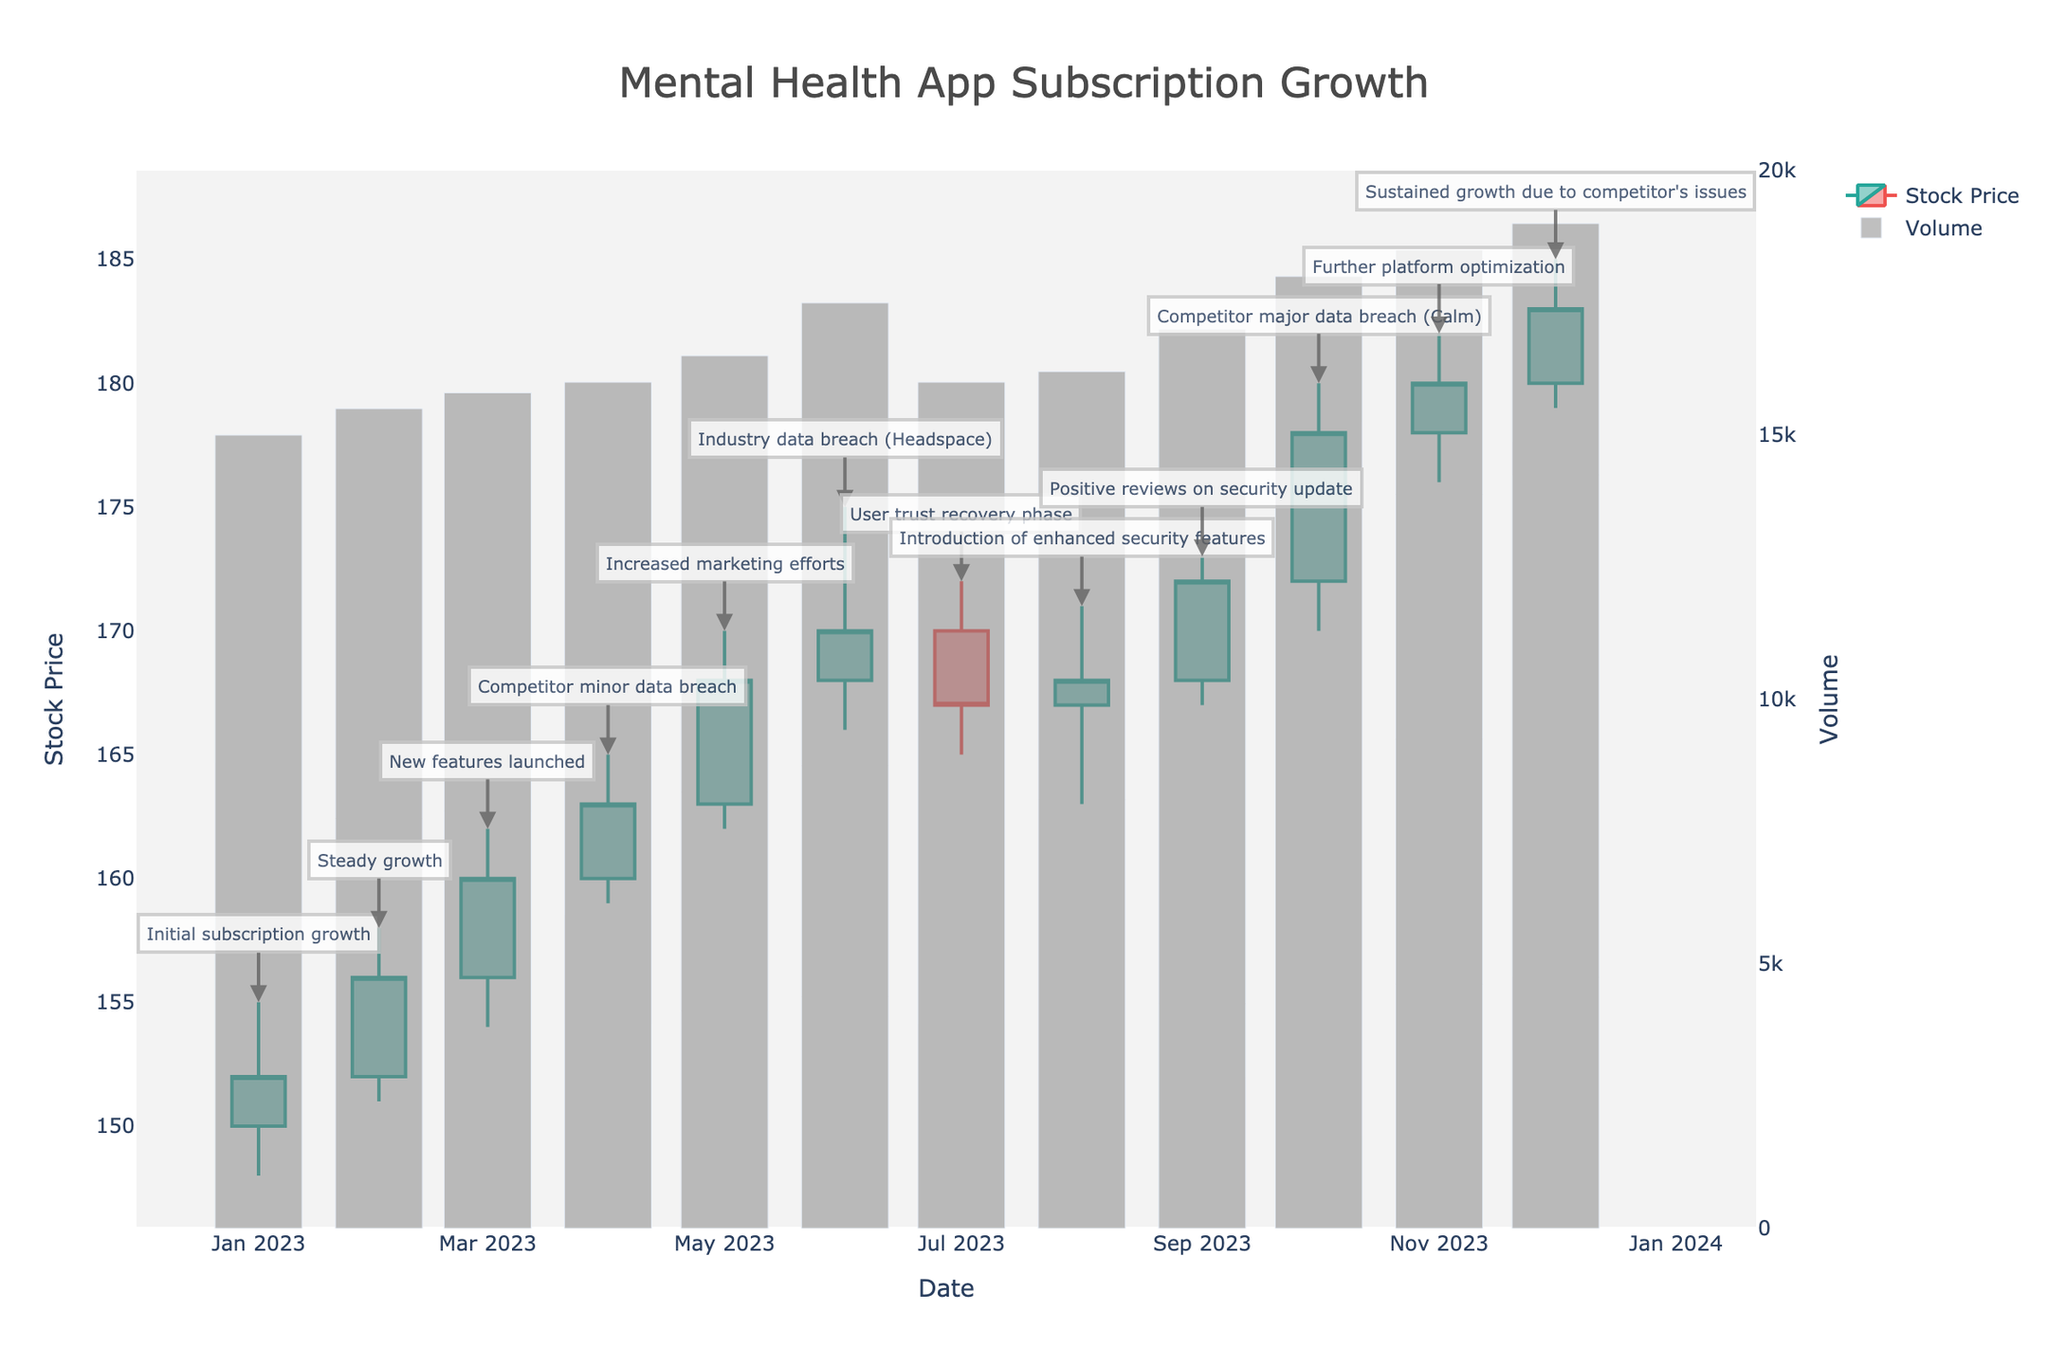what is the title of the candlestick plot? The title of the candlestick plot is visually presented at the top, center-aligned, and typically displayed in a larger and bolder font to make it stand out.
Answer: Mental Health App Subscription Growth How many data points (months) are depicted in the plot? To determine the number of data points, we count the distinct dates on the x-axis. Each date represents a month.
Answer: 12 When did the stock price reach its highest high? We need to identify the highest point on the plot's y-axis representing the stock price, then check the associated date on the x-axis.
Answer: October 2023 What is the volume trend in November 2023 compared to the previous month? First, identify the volume bars for October and November 2023. Then, compare their lengths to see if November's volume is higher or lower.
Answer: Higher Which event correlates with the largest increase in volume? Look for the month with the tallest volume bar and then refer to the comments/annotations for that month in the plot.
Answer: Competitor major data breach (Calm) What was the stock price at the close of June 2023? Locate the candlestick for June 2023 and identify the closing price label, which is shown by the top or bottom of the thicker part of the candlestick, depending on the price movement.
Answer: 170 How did the introduction of enhanced security features in August 2023 impact the stock price? Examine the candlestick for August 2023 and observe any significant price changes from the previous month to determine the trend.
Answer: Slight increase (price remained stable around 167 to 168) Compare the stock performance during the industry's (Headspace) breach in June 2023 and the competitor's (Calm) breach in October 2023. Evaluate the candlesticks, annotations, and volume bars for June and October 2023, focusing on stock prices and volume movements to compare the impacts.
Answer: June showed a decrease and then slow recovery, October had a significant increase in price and volume What month shows evidence of a recovery phase after the decline? Look for a month following a steep decline where the prices stabilize or start rising again, then check the comments for any mention of recovery.
Answer: July 2023 Is there a correlation between the launch of new features in March 2023 and subscription growth? Review the candlestick for March 2023 to see if there is a notable increase in the closing price or volume compared to the previous month, reflecting positive subscription growth.
Answer: Yes, significant increase 